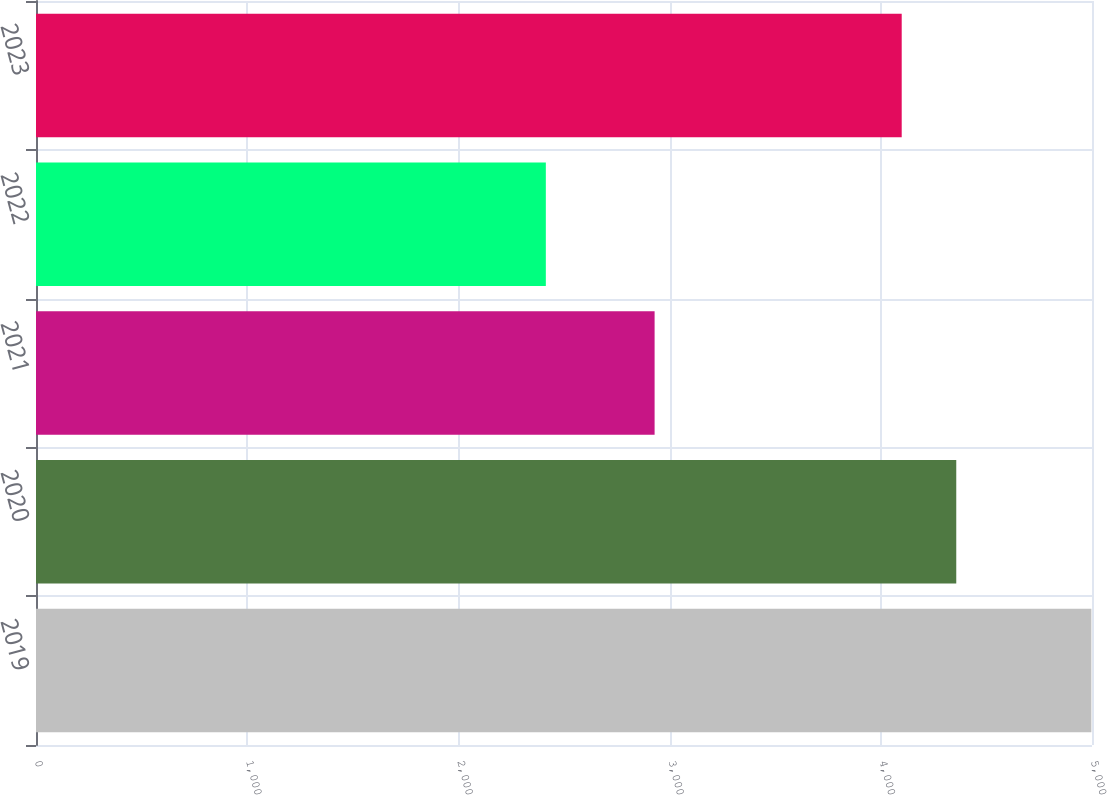Convert chart to OTSL. <chart><loc_0><loc_0><loc_500><loc_500><bar_chart><fcel>2019<fcel>2020<fcel>2021<fcel>2022<fcel>2023<nl><fcel>4997<fcel>4357.3<fcel>2929<fcel>2414<fcel>4099<nl></chart> 